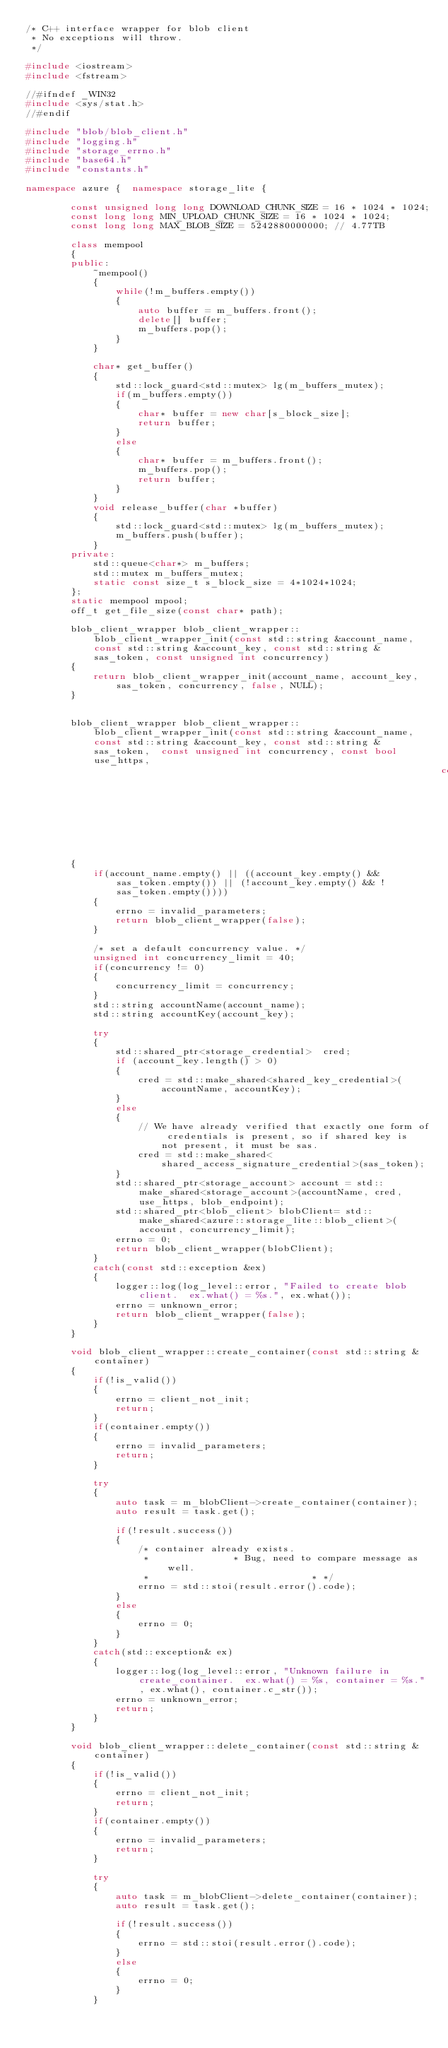<code> <loc_0><loc_0><loc_500><loc_500><_C++_>/* C++ interface wrapper for blob client
 * No exceptions will throw.
 */

#include <iostream>
#include <fstream>

//#ifndef _WIN32
#include <sys/stat.h>
//#endif

#include "blob/blob_client.h"
#include "logging.h"
#include "storage_errno.h"
#include "base64.h"
#include "constants.h"

namespace azure {  namespace storage_lite {

        const unsigned long long DOWNLOAD_CHUNK_SIZE = 16 * 1024 * 1024;
        const long long MIN_UPLOAD_CHUNK_SIZE = 16 * 1024 * 1024;
        const long long MAX_BLOB_SIZE = 5242880000000; // 4.77TB 

        class mempool
        {
        public:
            ~mempool()
            {
                while(!m_buffers.empty())
                {
                    auto buffer = m_buffers.front();
                    delete[] buffer;
                    m_buffers.pop();
                }
            }

            char* get_buffer()
            {
                std::lock_guard<std::mutex> lg(m_buffers_mutex);
                if(m_buffers.empty())
                {
                    char* buffer = new char[s_block_size];
                    return buffer;
                }
                else
                {
                    char* buffer = m_buffers.front();
                    m_buffers.pop();
                    return buffer;
                }
            }
            void release_buffer(char *buffer)
            {
                std::lock_guard<std::mutex> lg(m_buffers_mutex);
                m_buffers.push(buffer);
            }
        private:
            std::queue<char*> m_buffers;
            std::mutex m_buffers_mutex;
            static const size_t s_block_size = 4*1024*1024;
        };
        static mempool mpool;
        off_t get_file_size(const char* path);

        blob_client_wrapper blob_client_wrapper::blob_client_wrapper_init(const std::string &account_name, const std::string &account_key, const std::string &sas_token, const unsigned int concurrency)
        {
            return blob_client_wrapper_init(account_name, account_key, sas_token, concurrency, false, NULL);
        }


        blob_client_wrapper blob_client_wrapper::blob_client_wrapper_init(const std::string &account_name, const std::string &account_key, const std::string &sas_token,  const unsigned int concurrency, const bool use_https, 
                                                                          const std::string &blob_endpoint)
        {
            if(account_name.empty() || ((account_key.empty() && sas_token.empty()) || (!account_key.empty() && !sas_token.empty())))
            {
                errno = invalid_parameters;
                return blob_client_wrapper(false);
            }

            /* set a default concurrency value. */
            unsigned int concurrency_limit = 40;
            if(concurrency != 0)
            {
                concurrency_limit = concurrency;
            }
            std::string accountName(account_name);
            std::string accountKey(account_key);

            try
            {
                std::shared_ptr<storage_credential>  cred;
                if (account_key.length() > 0) 
                {
                    cred = std::make_shared<shared_key_credential>(accountName, accountKey);
                }
                else
                {
                    // We have already verified that exactly one form of credentials is present, so if shared key is not present, it must be sas.
                    cred = std::make_shared<shared_access_signature_credential>(sas_token);
                }
                std::shared_ptr<storage_account> account = std::make_shared<storage_account>(accountName, cred, use_https, blob_endpoint);
                std::shared_ptr<blob_client> blobClient= std::make_shared<azure::storage_lite::blob_client>(account, concurrency_limit);
                errno = 0;
                return blob_client_wrapper(blobClient);
            }
            catch(const std::exception &ex)
            {
                logger::log(log_level::error, "Failed to create blob client.  ex.what() = %s.", ex.what());
                errno = unknown_error;
                return blob_client_wrapper(false);
            }
        }

        void blob_client_wrapper::create_container(const std::string &container)
        {
            if(!is_valid())
            {
                errno = client_not_init;
                return;
            }
            if(container.empty())
            {
                errno = invalid_parameters;
                return;
            }

            try
            {
                auto task = m_blobClient->create_container(container);
                auto result = task.get();

                if(!result.success())
                {
                    /* container already exists.
                     *               * Bug, need to compare message as well.
                     *                             * */
                    errno = std::stoi(result.error().code);
                }
                else
                {
                    errno = 0;
                }
            }
            catch(std::exception& ex)
            {
                logger::log(log_level::error, "Unknown failure in create_container.  ex.what() = %s, container = %s.", ex.what(), container.c_str());
                errno = unknown_error;
                return;
            }
        }

        void blob_client_wrapper::delete_container(const std::string &container)
        {
            if(!is_valid())
            {
                errno = client_not_init;
                return;
            }
            if(container.empty())
            {
                errno = invalid_parameters;
                return;
            }

            try
            {
                auto task = m_blobClient->delete_container(container);
                auto result = task.get();

                if(!result.success())
                {
                    errno = std::stoi(result.error().code);
                }
                else
                {
                    errno = 0;
                }
            }</code> 